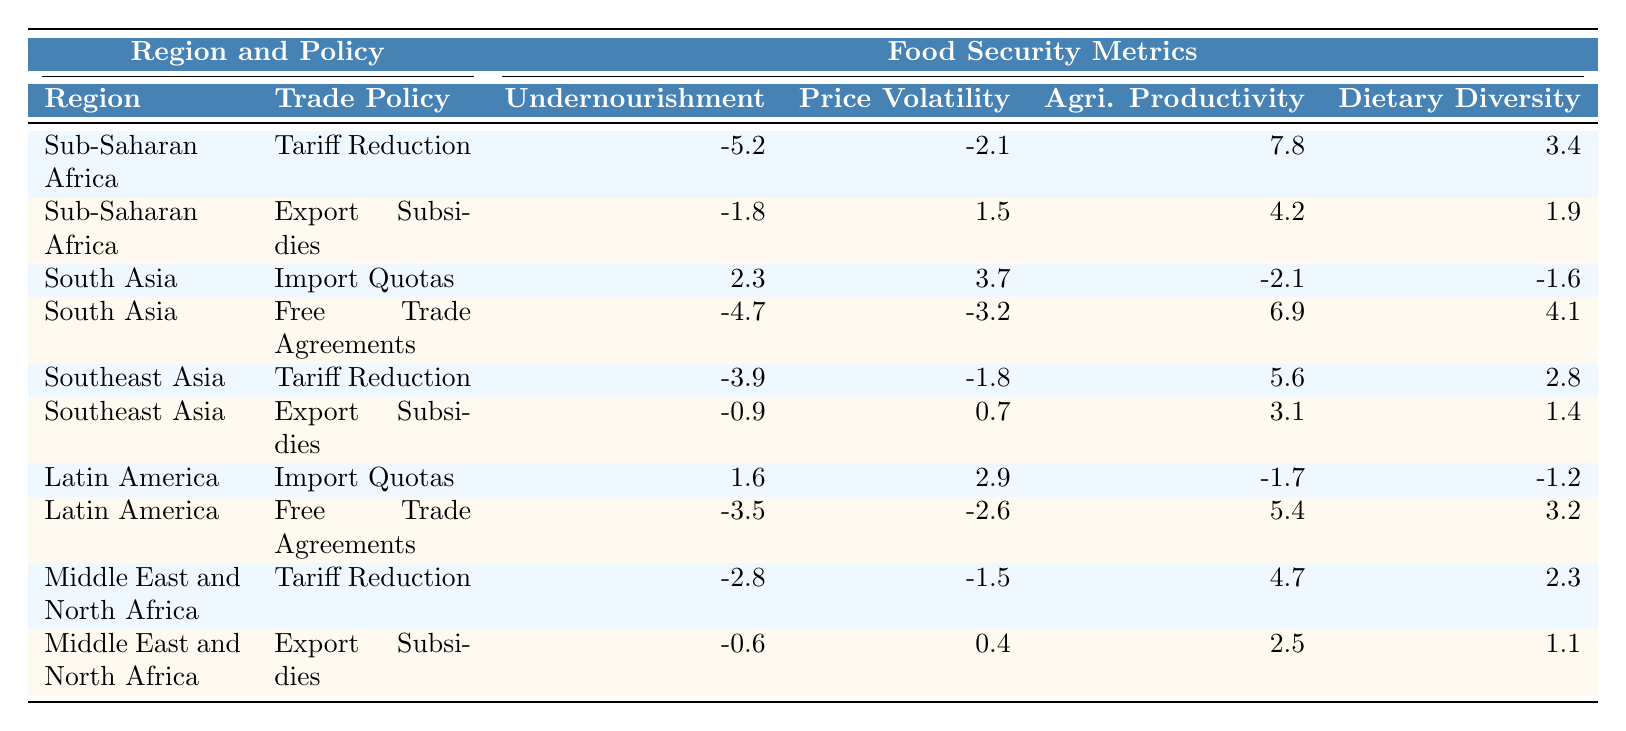What is the impact of Tariff Reduction on the Prevalence of Undernourishment in Sub-Saharan Africa? The table shows that the value for Prevalence of Undernourishment under Tariff Reduction in Sub-Saharan Africa is -5.2. This indicates a reduction in undernourishment by 5.2 percentage points.
Answer: -5.2 Which trade policy in South Asia has the worst impact on Agricultural Productivity? The table indicates that Import Quotas have an Agricultural Productivity value of -2.1, which is lower than the -4.7 from Free Trade Agreements. Therefore, Import Quotas have the worst impact.
Answer: Import Quotas What is the difference in the impact on Dietary Diversity between Free Trade Agreements and Import Quotas in Latin America? The values for Dietary Diversity are 3.2 for Free Trade Agreements and -1.2 for Import Quotas. The difference is 3.2 - (-1.2) = 4.4, meaning Free Trade Agreements improve Dietary Diversity significantly compared to Import Quotas.
Answer: 4.4 Is it true that Export Subsidies in the Middle East and North Africa improve the Prevalence of Undernourishment? The table shows that under Export Subsidies, the value for Prevalence of Undernourishment is -0.6, indicating a small reduction, so it does not improve the situation.
Answer: No Which region experienced the highest increase in Agricultural Productivity from Free Trade Agreements? In the table, South Asia shows an increase of 6.9 in Agricultural Productivity from Free Trade Agreements, which is the highest compared to the other regions.
Answer: South Asia What is the average change in Prevalence of Undernourishment across all regions for Export Subsidies? For Export Subsidies, the values are -1.8 (Sub-Saharan Africa), -0.6 (Middle East and North Africa), and -0.9 (Southeast Asia). The average is calculated as (-1.8 + -0.6 + -0.9) / 3 = -1.43.
Answer: -1.43 If the aim is to reduce Food Price Volatility, which trade policy should be preferred in Latin America? In Latin America, Free Trade Agreements have a Food Price Volatility value of -2.6 compared to 2.9 from Import Quotas. Therefore, Free Trade Agreements should be preferred.
Answer: Free Trade Agreements How does the impact of Tariff Reduction on Dairy Diversity in Southeast Asia compare to Export Subsidies? The value for Dietary Diversity under Tariff Reduction is 2.8 while under Export Subsidies it is 1.4. Thus, Tariff Reduction has a better impact on Dietary Diversity than Export Subsidies in Southeast Asia.
Answer: Tariff Reduction What is the total impact on Food Price Volatility from Tariff Reduction policies across all regions? The values for Food Price Volatility from Tariff Reduction are -2.1 (Sub-Saharan Africa), -1.8 (Southeast Asia), and -1.5 (Middle East and North Africa). The total impact is calculated as (-2.1 - 1.8 - 1.5) = -5.4.
Answer: -5.4 In which region does Export Subsidies have the least negative impact on Agricultural Productivity? The values for Agricultural Productivity under Export Subsidies are 4.2 (Sub-Saharan Africa), 2.5 (Middle East and North Africa), and 3.1 (Southeast Asia). 2.5 is the least, so Middle East and North Africa has the least negative impact.
Answer: Middle East and North Africa 